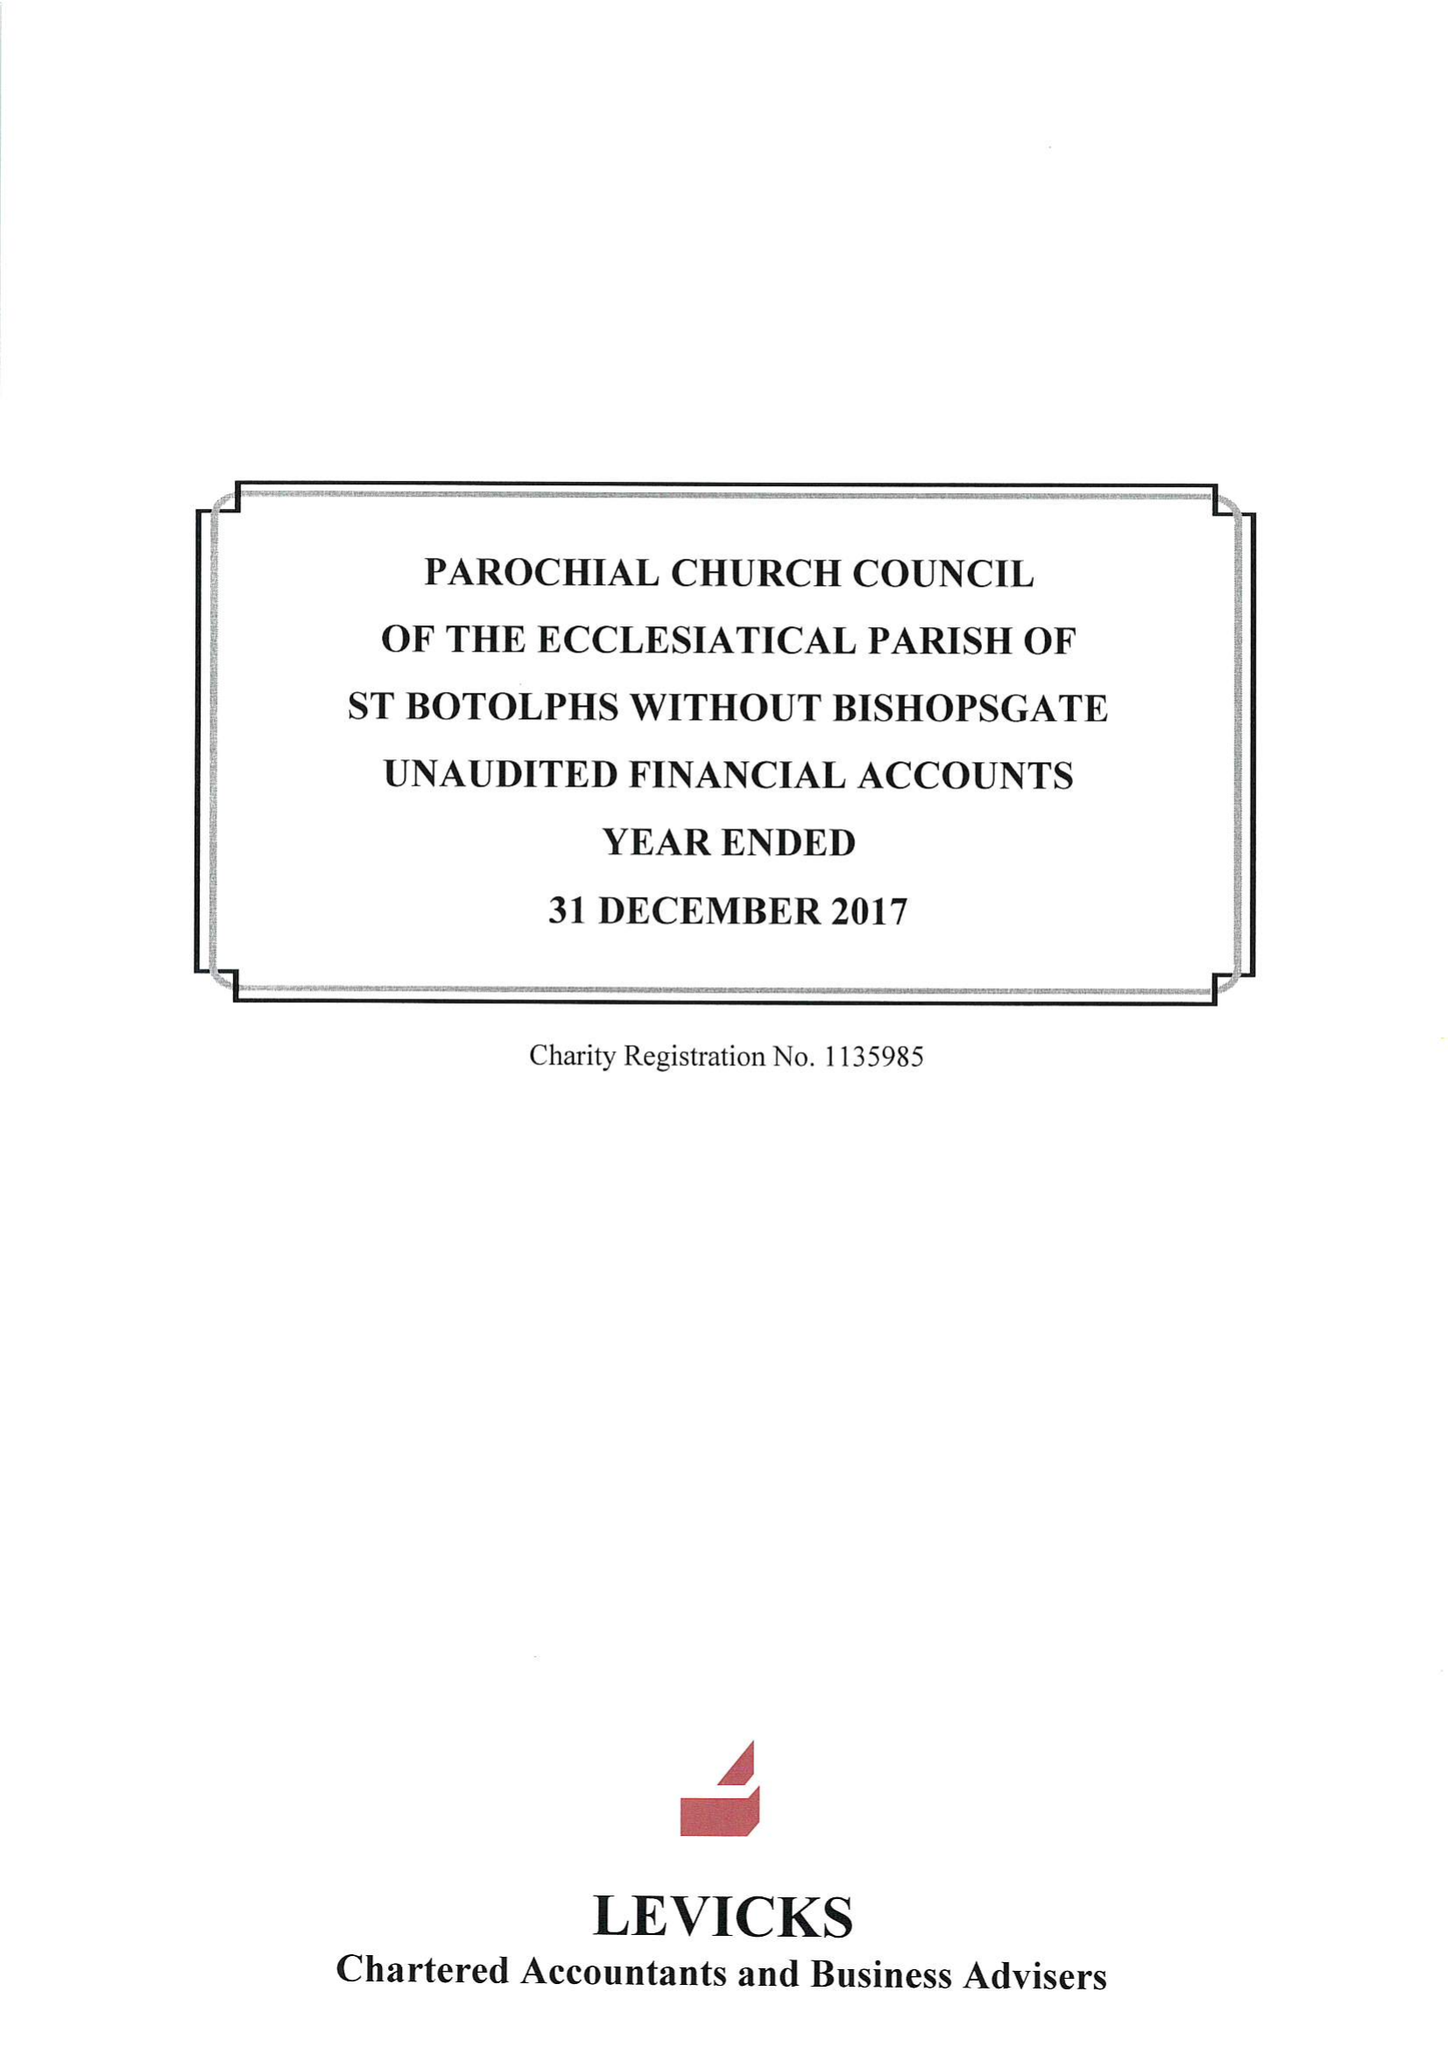What is the value for the address__street_line?
Answer the question using a single word or phrase. BISHOPSGATE 